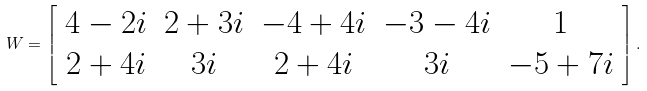<formula> <loc_0><loc_0><loc_500><loc_500>W = \left [ \begin{array} { c c c c c } 4 - 2 i & 2 + 3 i & - 4 + 4 i & - 3 - 4 i & 1 \\ 2 + 4 i & 3 i & 2 + 4 i & 3 i & - 5 + 7 i \\ \end{array} \right ] .</formula> 